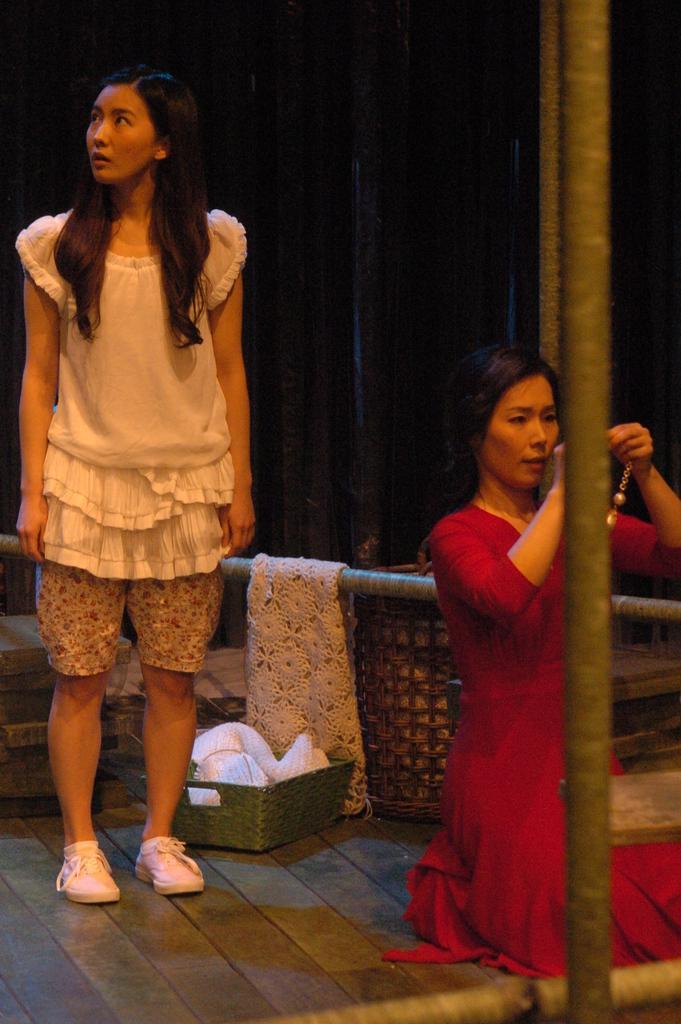Could you give a brief overview of what you see in this image? In this image I can see two women among them this woman is holding something in hands. I can also see clothes, poles and other objects on the floor. 